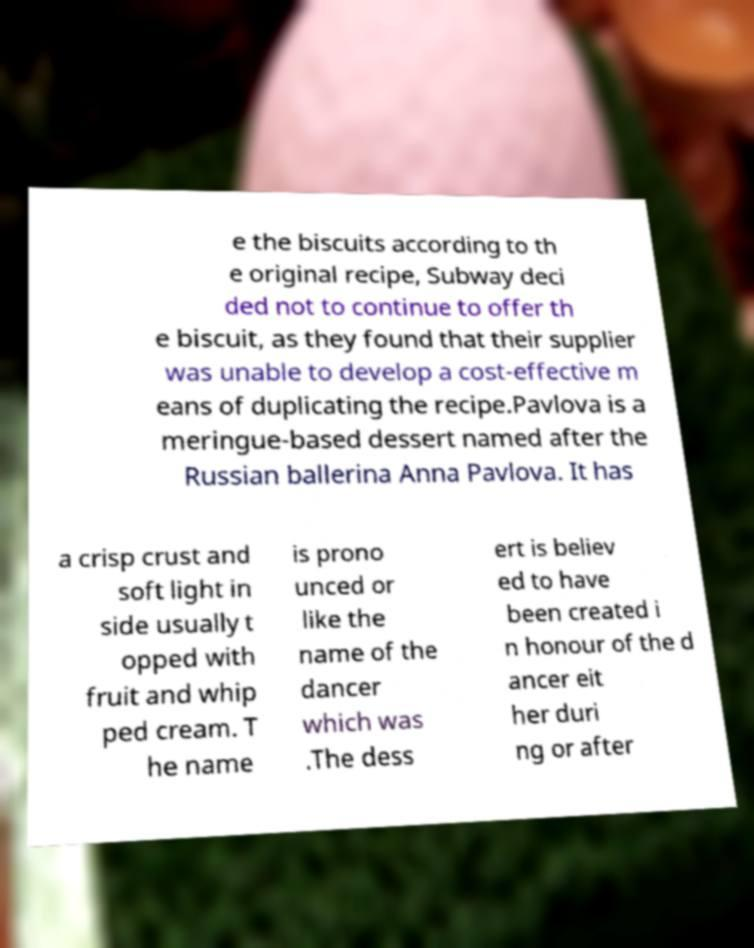Please read and relay the text visible in this image. What does it say? e the biscuits according to th e original recipe, Subway deci ded not to continue to offer th e biscuit, as they found that their supplier was unable to develop a cost-effective m eans of duplicating the recipe.Pavlova is a meringue-based dessert named after the Russian ballerina Anna Pavlova. It has a crisp crust and soft light in side usually t opped with fruit and whip ped cream. T he name is prono unced or like the name of the dancer which was .The dess ert is believ ed to have been created i n honour of the d ancer eit her duri ng or after 